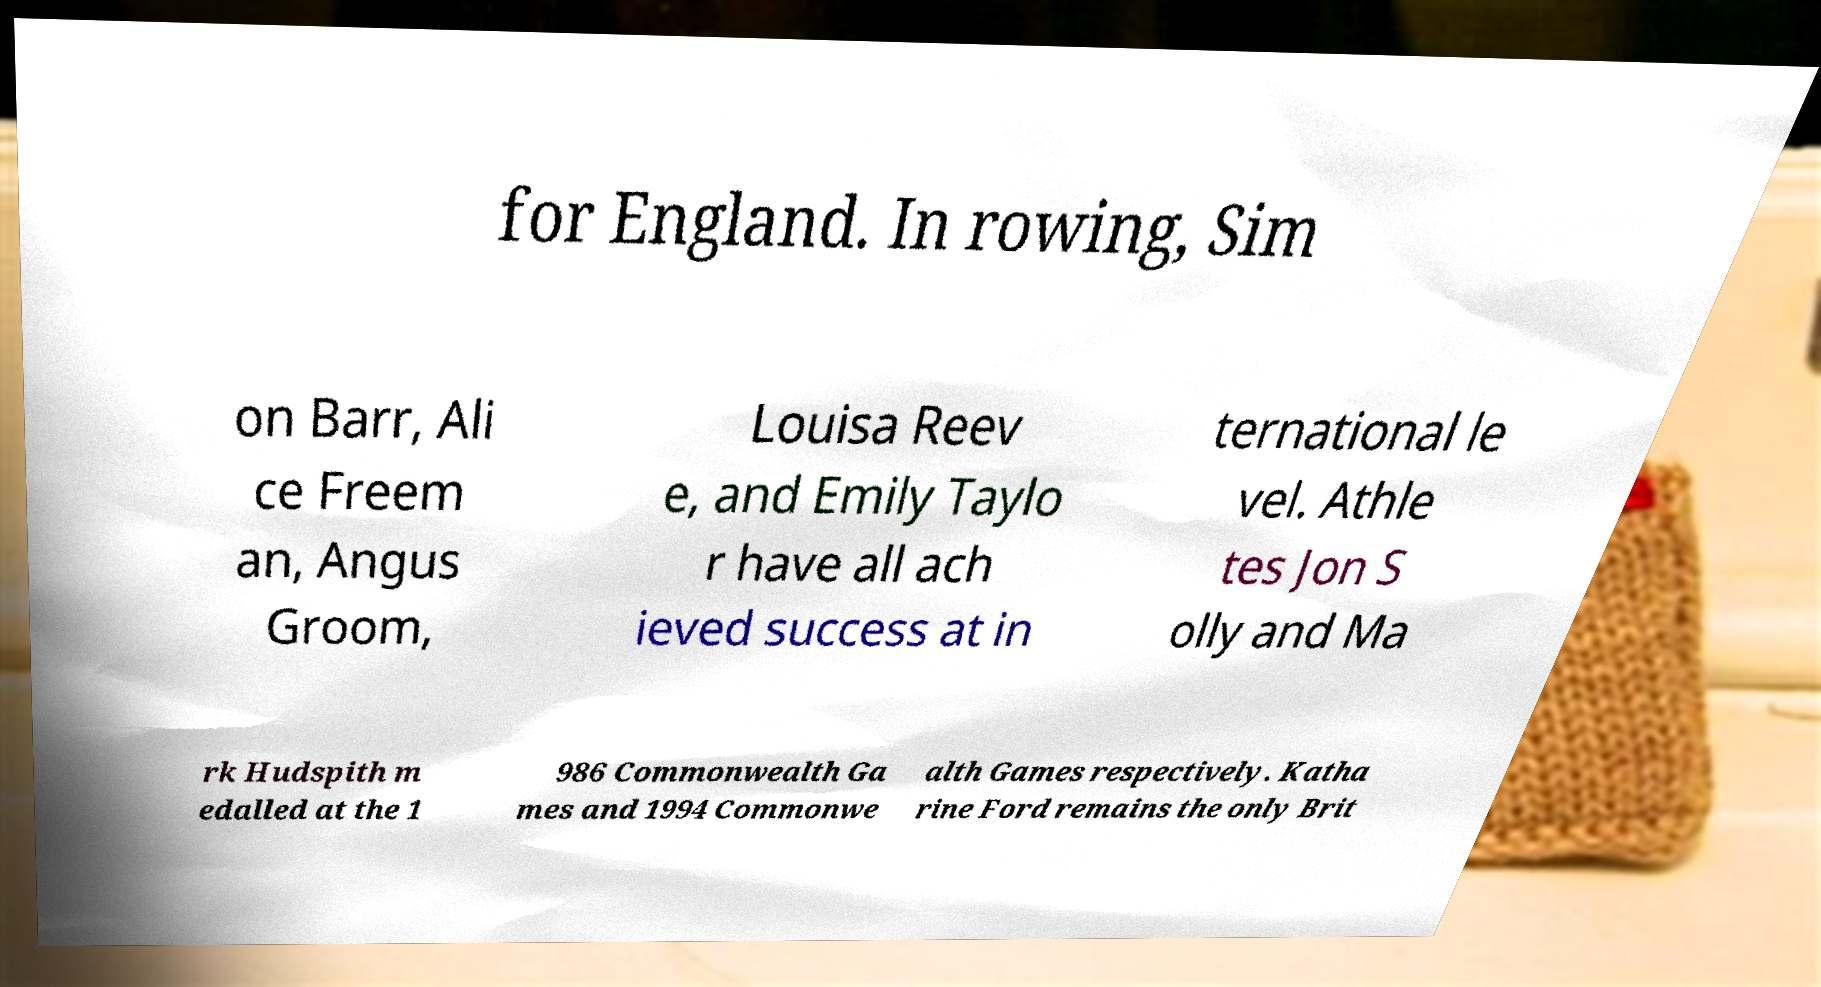For documentation purposes, I need the text within this image transcribed. Could you provide that? for England. In rowing, Sim on Barr, Ali ce Freem an, Angus Groom, Louisa Reev e, and Emily Taylo r have all ach ieved success at in ternational le vel. Athle tes Jon S olly and Ma rk Hudspith m edalled at the 1 986 Commonwealth Ga mes and 1994 Commonwe alth Games respectively. Katha rine Ford remains the only Brit 